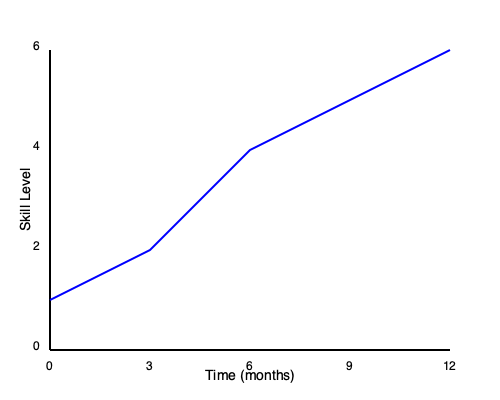Based on the line graph showing a child's progress in Taekwondo over 12 months, calculate the average rate of skill level increase per month. How might this information be used to adjust mental training techniques for the child? To solve this problem and understand its implications for mental training, let's follow these steps:

1. Identify the initial and final skill levels:
   - Initial skill level (0 months): 1
   - Final skill level (12 months): 6

2. Calculate the total increase in skill level:
   $\text{Total increase} = \text{Final level} - \text{Initial level} = 6 - 1 = 5$

3. Calculate the average rate of skill level increase per month:
   $\text{Average rate} = \frac{\text{Total increase}}{\text{Time period}} = \frac{5}{12} \approx 0.417$ skill levels per month

4. Interpreting the result for mental training:
   a) The consistent upward trend suggests that the child is making steady progress, which can be used to reinforce positive self-talk and boost confidence.
   
   b) The steeper slope in the first 6 months compared to the last 6 months indicates faster initial progress. This information can be used to:
      - Prepare the child mentally for potentially slower progress as they advance.
      - Adjust goal-setting strategies to maintain motivation during periods of slower growth.
   
   c) The average rate of 0.417 skill levels per month can be used to set realistic expectations and short-term goals for the child.
   
   d) Visualization techniques can be tailored to focus on specific skills that contribute to level advancement, using the graph as a visual aid for progress tracking.
   
   e) Mental rehearsal exercises can be designed to target skills at the next anticipated level, preparing the child for upcoming challenges.

5. Adjusting mental training techniques:
   - Use the graph in goal-setting sessions to help the child visualize their progress and future potential.
   - Implement mindfulness techniques to help the child stay focused on current skill development, especially during periods of slower progress.
   - Develop coping strategies for potential plateaus, using the graph to illustrate that progress may not always be linear.
   - Create mental imagery scripts that align with the skill levels shown on the graph, helping the child prepare for each new stage of development.

By using this data-driven approach, mental training techniques can be more precisely tailored to the child's developmental trajectory in Taekwondo, enhancing both performance and psychological well-being.
Answer: 0.417 skill levels/month; use for goal-setting, expectation management, and tailored visualization techniques. 